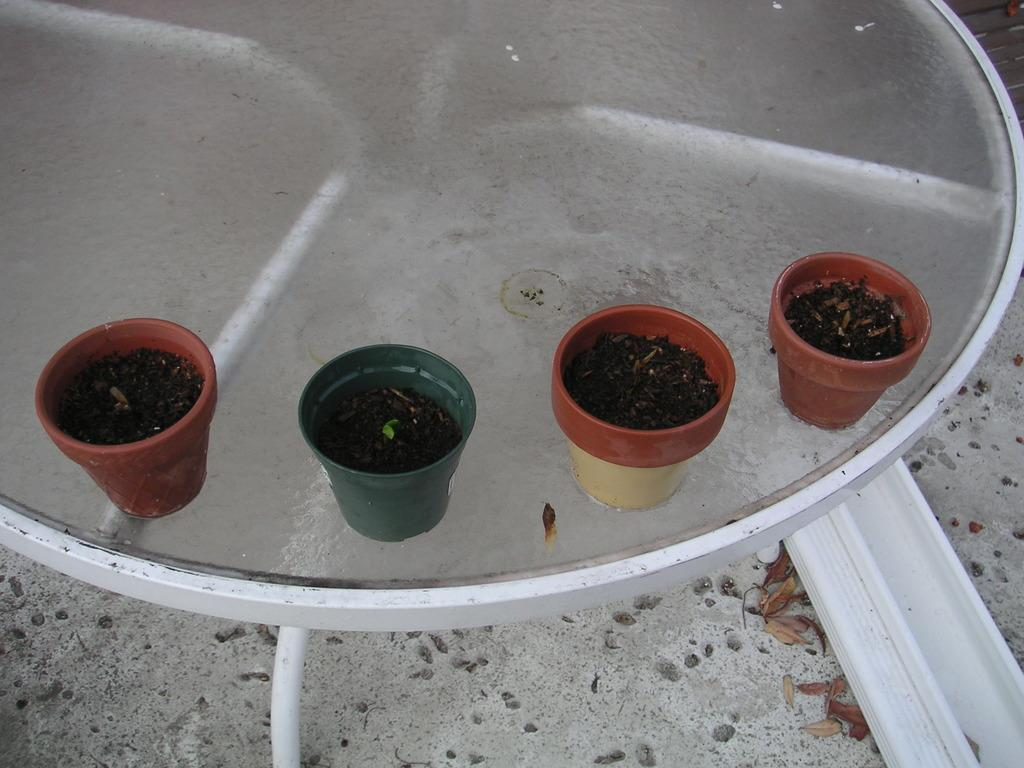What objects are present in the image? There are pots in the image. What is inside the pots? The pots contain mud. Where are the pots located? The pots are on a table. What is the condition of the parcel in the image? There is no parcel present in the image. 